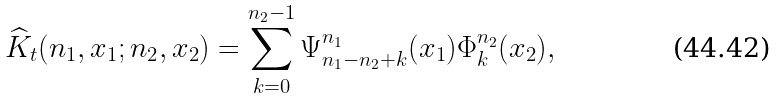Convert formula to latex. <formula><loc_0><loc_0><loc_500><loc_500>\widehat { K } _ { t } ( n _ { 1 } , x _ { 1 } ; n _ { 2 } , x _ { 2 } ) = \sum _ { k = 0 } ^ { n _ { 2 } - 1 } \Psi ^ { n _ { 1 } } _ { n _ { 1 } - n _ { 2 } + k } ( x _ { 1 } ) \Phi ^ { n _ { 2 } } _ { k } ( x _ { 2 } ) ,</formula> 